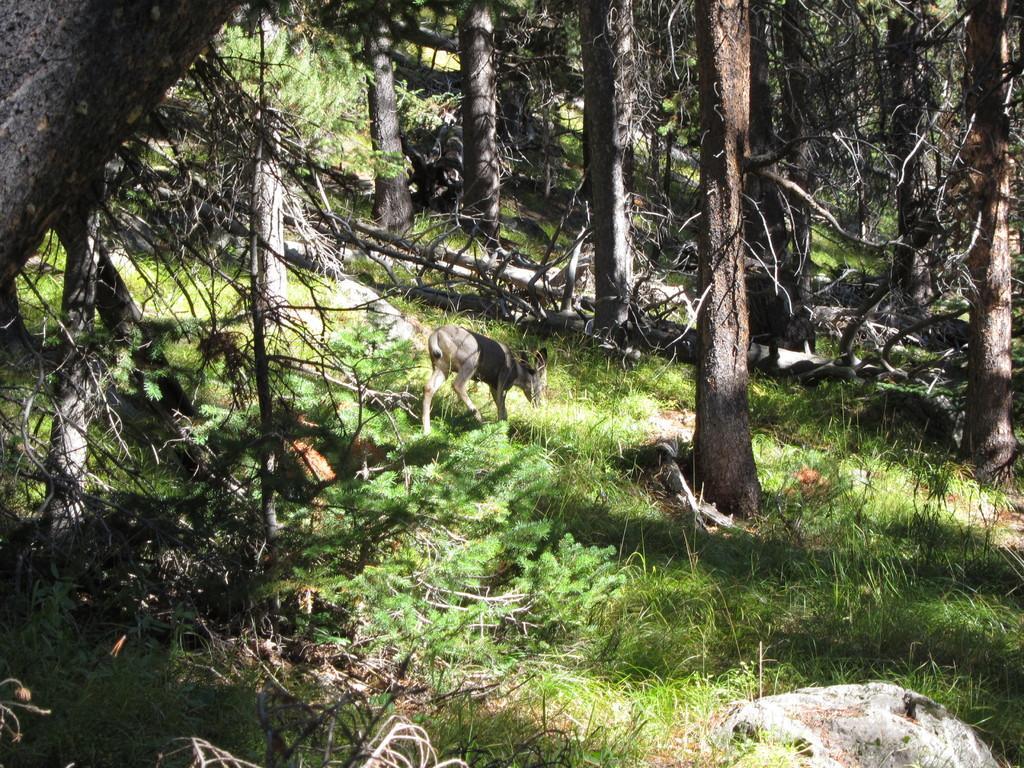Could you give a brief overview of what you see in this image? In this image I can see the ground, some grass on the ground, a rock and few trees. I can see an animal is standing on the ground. 